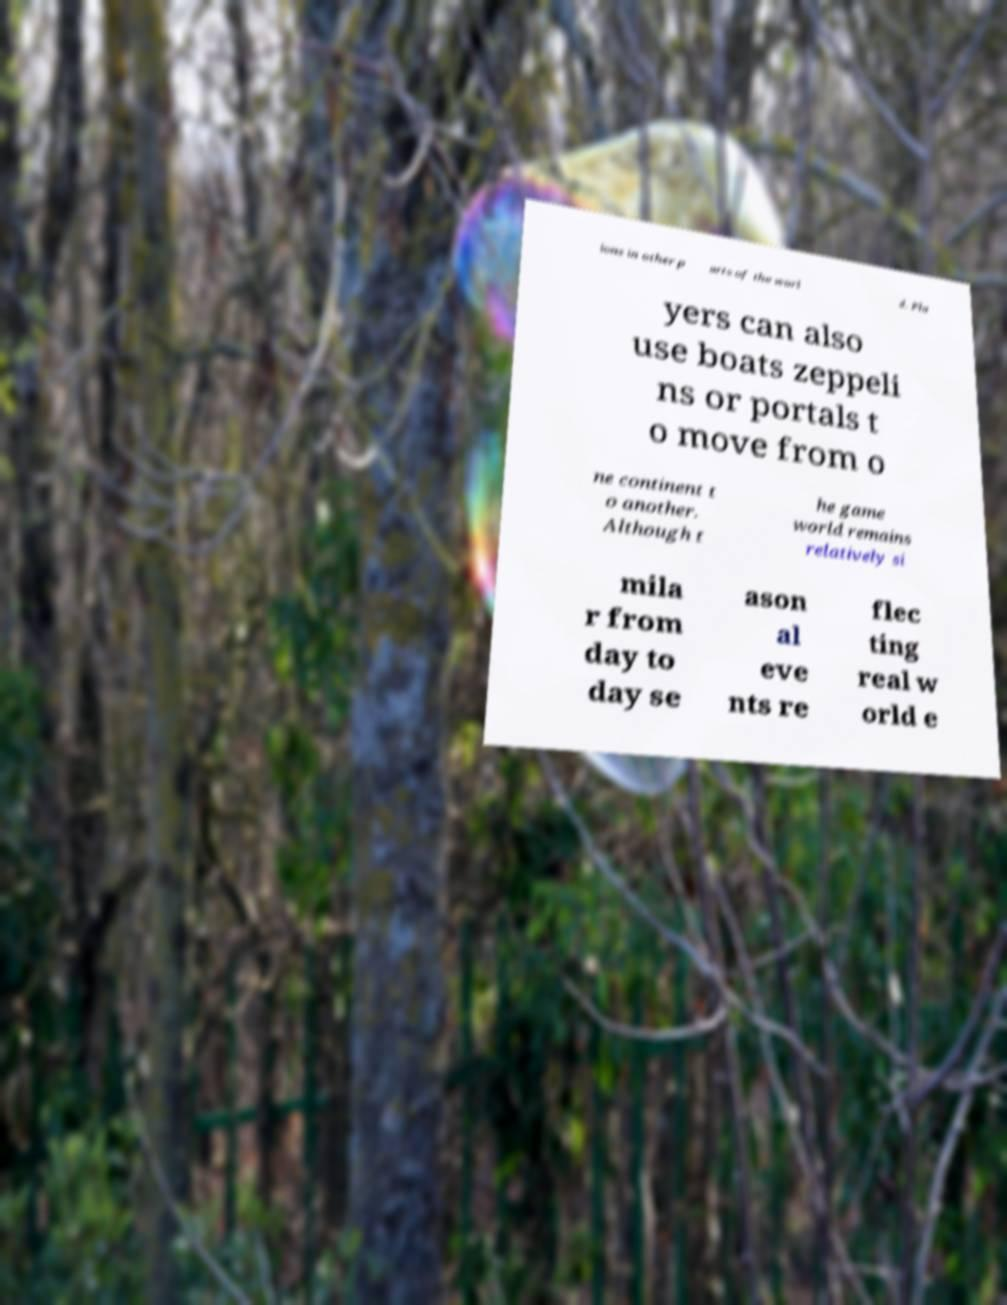What messages or text are displayed in this image? I need them in a readable, typed format. ions in other p arts of the worl d. Pla yers can also use boats zeppeli ns or portals t o move from o ne continent t o another. Although t he game world remains relatively si mila r from day to day se ason al eve nts re flec ting real w orld e 